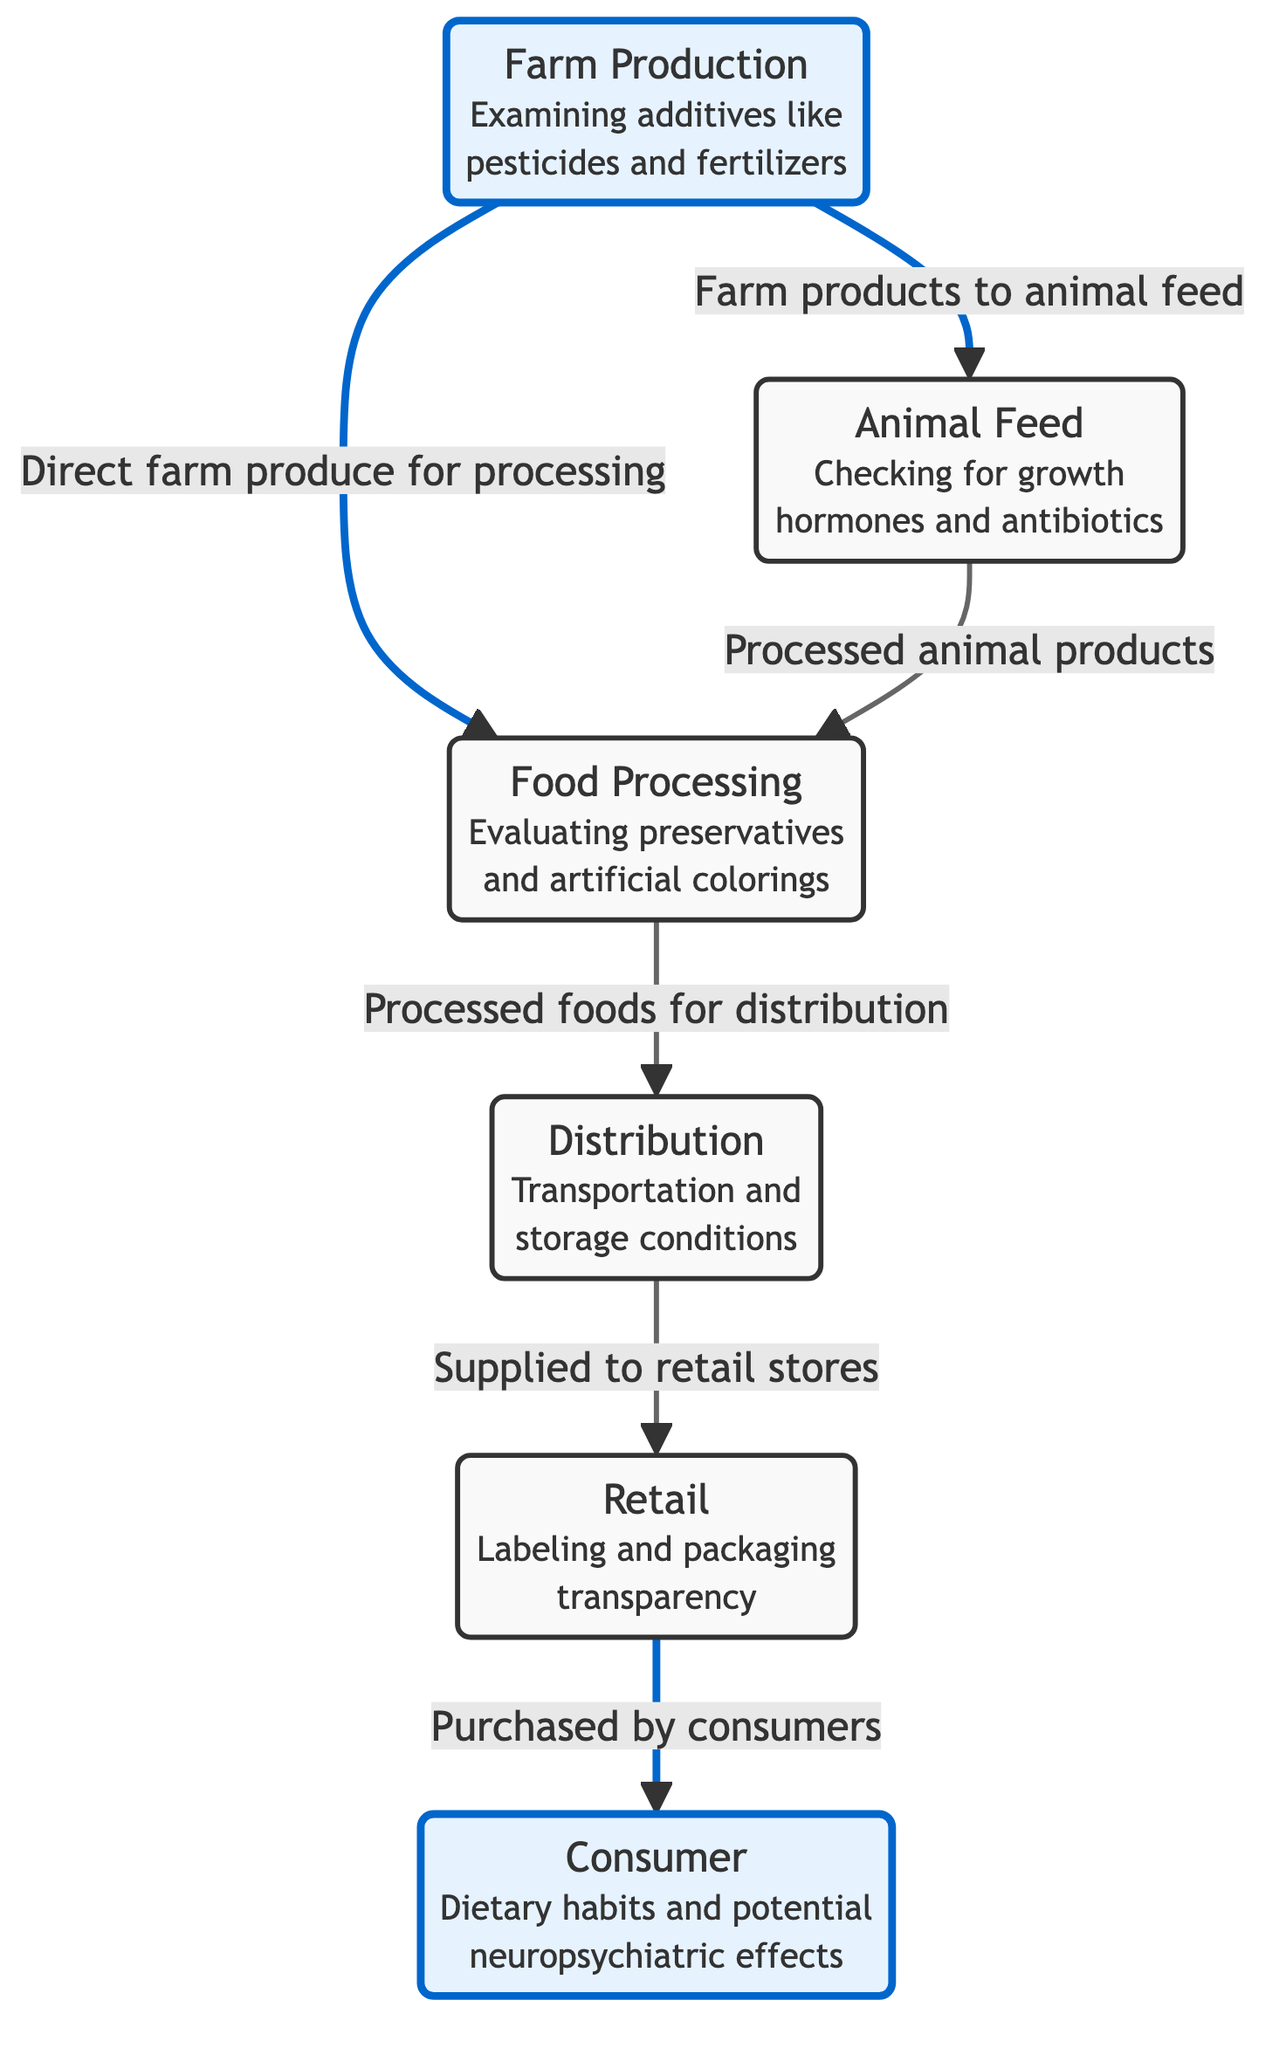What is the first step in the food chain? The first step in the food chain is "Farm Production," which is where additives like pesticides and fertilizers are examined.
Answer: Farm Production How many main nodes are present in the diagram? The diagram contains six main nodes: Farm Production, Animal Feed, Food Processing, Distribution, Retail, and Consumer.
Answer: 6 Which node involves the checking of growth hormones? The node that involves the checking of growth hormones is "Animal Feed." It focuses on the additives used in animal feed, including growth hormones and antibiotics.
Answer: Animal Feed What is the last step before consumers purchase food? The last step before consumers purchase food is "Retail," which includes labeling and packaging transparency.
Answer: Retail Which two nodes are connected directly by the "Processed foods for distribution"? The two nodes connected directly by "Processed foods for distribution" are "Food Processing" and "Distribution." This connection indicates that processed foods move from processing to distribution.
Answer: Food Processing and Distribution How do farm products contribute to animal feed? Farm products contribute to animal feed through direct supply from "Farm Production," which involves products grown on the farm being used as feed.
Answer: Direct farm products to animal feed What type of effects are consumers potentially affected by? Consumers are potentially affected by "neuropsychiatric effects," which are examined in relation to their dietary habits.
Answer: Neuropsychiatric effects Which node is emphasized in blue highlighting? The nodes that are emphasized in blue highlighting are "Farm Production" and "Consumer," indicating their importance in the food chain regarding additives and effects.
Answer: Farm Production and Consumer 